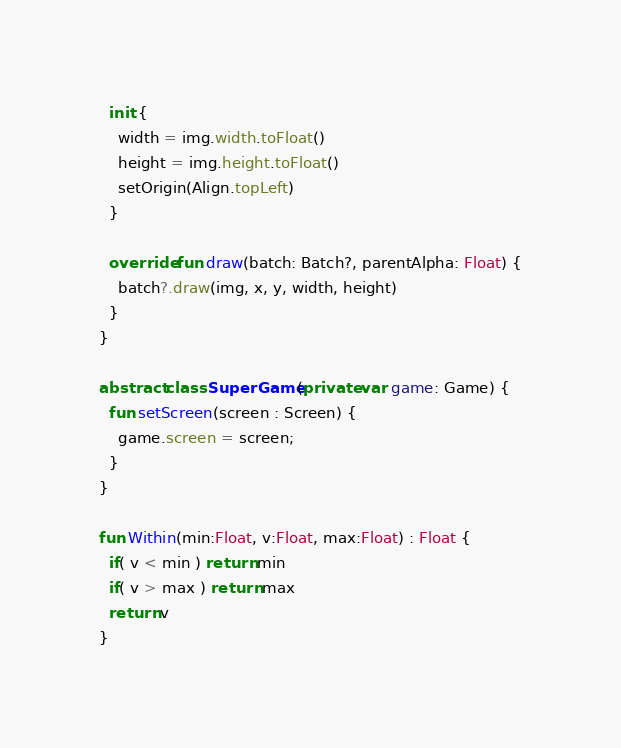<code> <loc_0><loc_0><loc_500><loc_500><_Kotlin_>  init {
    width = img.width.toFloat()
    height = img.height.toFloat()
    setOrigin(Align.topLeft)
  }

  override fun draw(batch: Batch?, parentAlpha: Float) {
    batch?.draw(img, x, y, width, height)
  }
}

abstract class SuperGame(private var game: Game) {
  fun setScreen(screen : Screen) {
    game.screen = screen;
  }
}

fun Within(min:Float, v:Float, max:Float) : Float {
  if( v < min ) return min
  if( v > max ) return max
  return v
}
</code> 